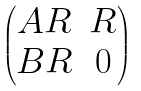Convert formula to latex. <formula><loc_0><loc_0><loc_500><loc_500>\begin{pmatrix} A R & R \\ B R & 0 \end{pmatrix}</formula> 